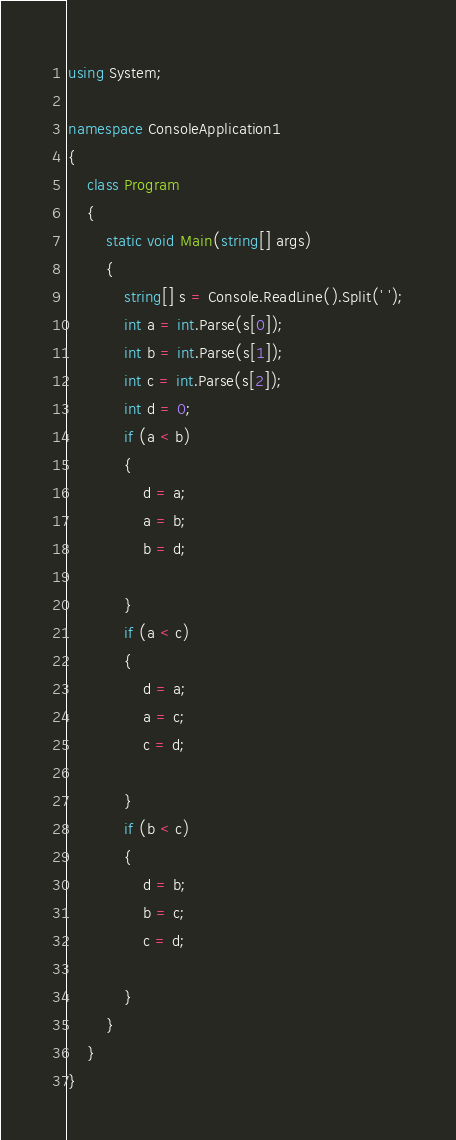<code> <loc_0><loc_0><loc_500><loc_500><_C#_>using System;

namespace ConsoleApplication1
{
    class Program
    {
        static void Main(string[] args)
        {
            string[] s = Console.ReadLine().Split(' ');
            int a = int.Parse(s[0]);
            int b = int.Parse(s[1]);
            int c = int.Parse(s[2]);
            int d = 0;
            if (a < b)
            {
                d = a;
                a = b;
                b = d;

            }
            if (a < c)
            {
                d = a;
                a = c;
                c = d;

            }
            if (b < c)
            {
                d = b;
                b = c;
                c = d;

            }
        }
    }
}</code> 